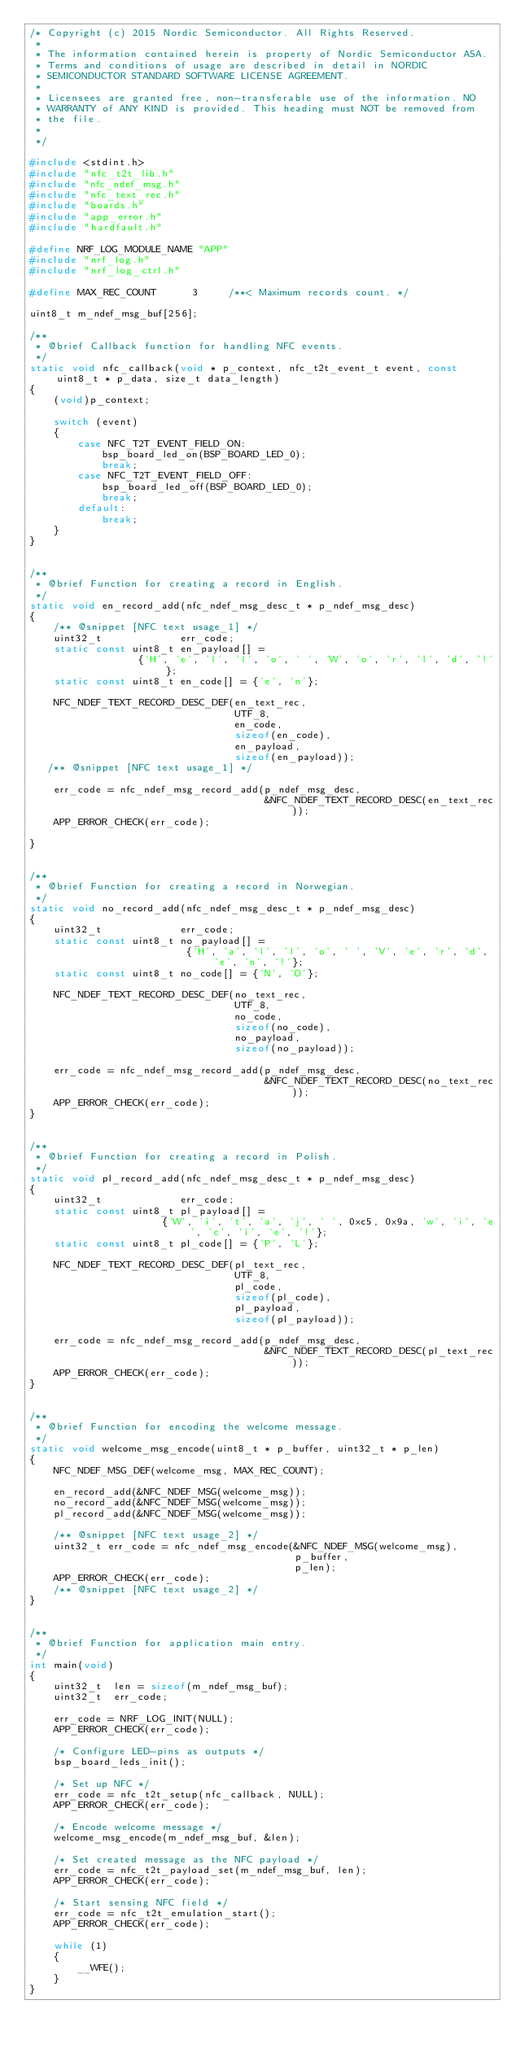Convert code to text. <code><loc_0><loc_0><loc_500><loc_500><_C_>/* Copyright (c) 2015 Nordic Semiconductor. All Rights Reserved.
 *
 * The information contained herein is property of Nordic Semiconductor ASA.
 * Terms and conditions of usage are described in detail in NORDIC
 * SEMICONDUCTOR STANDARD SOFTWARE LICENSE AGREEMENT.
 *
 * Licensees are granted free, non-transferable use of the information. NO
 * WARRANTY of ANY KIND is provided. This heading must NOT be removed from
 * the file.
 *
 */

#include <stdint.h>
#include "nfc_t2t_lib.h"
#include "nfc_ndef_msg.h"
#include "nfc_text_rec.h"
#include "boards.h"
#include "app_error.h"
#include "hardfault.h"

#define NRF_LOG_MODULE_NAME "APP"
#include "nrf_log.h"
#include "nrf_log_ctrl.h"

#define MAX_REC_COUNT      3     /**< Maximum records count. */

uint8_t m_ndef_msg_buf[256];

/**
 * @brief Callback function for handling NFC events.
 */
static void nfc_callback(void * p_context, nfc_t2t_event_t event, const uint8_t * p_data, size_t data_length)
{
    (void)p_context;

    switch (event)
    {
        case NFC_T2T_EVENT_FIELD_ON:
            bsp_board_led_on(BSP_BOARD_LED_0);
            break;
        case NFC_T2T_EVENT_FIELD_OFF:
            bsp_board_led_off(BSP_BOARD_LED_0);
            break;
        default:
            break;
    }
}


/**
 * @brief Function for creating a record in English.
 */
static void en_record_add(nfc_ndef_msg_desc_t * p_ndef_msg_desc)
{
    /** @snippet [NFC text usage_1] */
    uint32_t             err_code;
    static const uint8_t en_payload[] =
                  {'H', 'e', 'l', 'l', 'o', ' ', 'W', 'o', 'r', 'l', 'd', '!'};
    static const uint8_t en_code[] = {'e', 'n'};

    NFC_NDEF_TEXT_RECORD_DESC_DEF(en_text_rec,
                                  UTF_8,
                                  en_code,
                                  sizeof(en_code),
                                  en_payload,
                                  sizeof(en_payload));
   /** @snippet [NFC text usage_1] */

    err_code = nfc_ndef_msg_record_add(p_ndef_msg_desc,
                                       &NFC_NDEF_TEXT_RECORD_DESC(en_text_rec));
    APP_ERROR_CHECK(err_code);

}


/**
 * @brief Function for creating a record in Norwegian.
 */
static void no_record_add(nfc_ndef_msg_desc_t * p_ndef_msg_desc)
{
    uint32_t             err_code;
    static const uint8_t no_payload[] =
                          {'H', 'a', 'l', 'l', 'o', ' ', 'V', 'e', 'r', 'd', 'e', 'n', '!'};
    static const uint8_t no_code[] = {'N', 'O'};

    NFC_NDEF_TEXT_RECORD_DESC_DEF(no_text_rec,
                                  UTF_8,
                                  no_code,
                                  sizeof(no_code),
                                  no_payload,
                                  sizeof(no_payload));

    err_code = nfc_ndef_msg_record_add(p_ndef_msg_desc,
                                       &NFC_NDEF_TEXT_RECORD_DESC(no_text_rec));
    APP_ERROR_CHECK(err_code);
}


/**
 * @brief Function for creating a record in Polish.
 */
static void pl_record_add(nfc_ndef_msg_desc_t * p_ndef_msg_desc)
{
    uint32_t             err_code;
    static const uint8_t pl_payload[] =
                      {'W', 'i', 't', 'a', 'j', ' ', 0xc5, 0x9a, 'w', 'i', 'e', 'c', 'i', 'e', '!'};
    static const uint8_t pl_code[] = {'P', 'L'};

    NFC_NDEF_TEXT_RECORD_DESC_DEF(pl_text_rec,
                                  UTF_8,
                                  pl_code,
                                  sizeof(pl_code),
                                  pl_payload,
                                  sizeof(pl_payload));

    err_code = nfc_ndef_msg_record_add(p_ndef_msg_desc,
                                       &NFC_NDEF_TEXT_RECORD_DESC(pl_text_rec));
    APP_ERROR_CHECK(err_code);
}


/**
 * @brief Function for encoding the welcome message.
 */
static void welcome_msg_encode(uint8_t * p_buffer, uint32_t * p_len)
{
    NFC_NDEF_MSG_DEF(welcome_msg, MAX_REC_COUNT);

    en_record_add(&NFC_NDEF_MSG(welcome_msg));
    no_record_add(&NFC_NDEF_MSG(welcome_msg));
    pl_record_add(&NFC_NDEF_MSG(welcome_msg));

    /** @snippet [NFC text usage_2] */
    uint32_t err_code = nfc_ndef_msg_encode(&NFC_NDEF_MSG(welcome_msg),
                                            p_buffer,
                                            p_len);
    APP_ERROR_CHECK(err_code);
    /** @snippet [NFC text usage_2] */
}


/**
 * @brief Function for application main entry.
 */
int main(void)
{
    uint32_t  len = sizeof(m_ndef_msg_buf);
    uint32_t  err_code;

    err_code = NRF_LOG_INIT(NULL);
    APP_ERROR_CHECK(err_code);

    /* Configure LED-pins as outputs */
    bsp_board_leds_init();

    /* Set up NFC */
    err_code = nfc_t2t_setup(nfc_callback, NULL);
    APP_ERROR_CHECK(err_code);

    /* Encode welcome message */
    welcome_msg_encode(m_ndef_msg_buf, &len);

    /* Set created message as the NFC payload */
    err_code = nfc_t2t_payload_set(m_ndef_msg_buf, len);
    APP_ERROR_CHECK(err_code);

    /* Start sensing NFC field */
    err_code = nfc_t2t_emulation_start();
    APP_ERROR_CHECK(err_code);

    while (1)
    {
        __WFE();
    }
}

</code> 